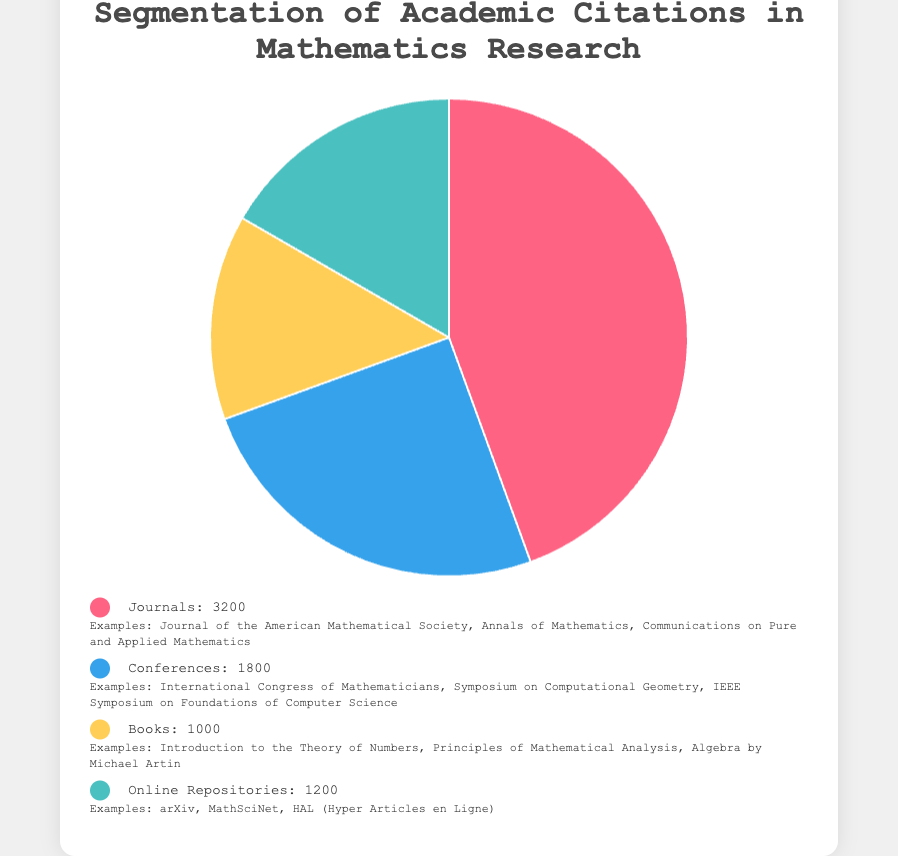Which source type has the highest number of citations? The pie chart shows that the largest segment corresponds to "Journals" with 3200 citations.
Answer: Journals What percentage of total citations does the "Online Repositories" category represent? The "Online Repositories" category has 1200 citations. The total number of citations is 3200 (Journals) + 1800 (Conferences) + 1000 (Books) + 1200 (Online Repositories) = 7200. The percentage is (1200 / 7200) * 100 = 16.7%.
Answer: 16.7% How many more citations do "Journals" have compared to "Books"? "Journals" have 3200 citations, and "Books" have 1000 citations. The difference is 3200 - 1000 = 2200.
Answer: 2200 What is the combined percentage of citations for "Books" and "Conferences"? "Books" have 1000 citations, and "Conferences" have 1800 citations. The total number of citations is 7200. The combined percentage is ((1000 + 1800) / 7200) * 100 = 38.9%.
Answer: 38.9% Which segment is represented by the yellow color in the chart? Looking at the chart and legend, the yellow color corresponds to the "Books" category.
Answer: Books If five new citations were added to the "Books" category, what would its new percentage be? "Books" currently have 1000 citations. With five new citations, the count would be 1005. The new total is 7200 + 5 = 7205. The new percentage is (1005 / 7205) * 100 = 14.0%.
Answer: 14.0% Rank the source types by the number of citations in ascending order. The source types and their citation counts are: Books (1000), Online Repositories (1200), Conferences (1800), and Journals (3200). In ascending order, it's Books, Online Repositories, Conferences, Journals.
Answer: Books, Online Repositories, Conferences, Journals Determine the ratio of citations between "Conferences" and "Journals". "Conferences" have 1800 citations, and "Journals" have 3200. The ratio is 1800:3200, which simplifies to 9:16.
Answer: 9:16 